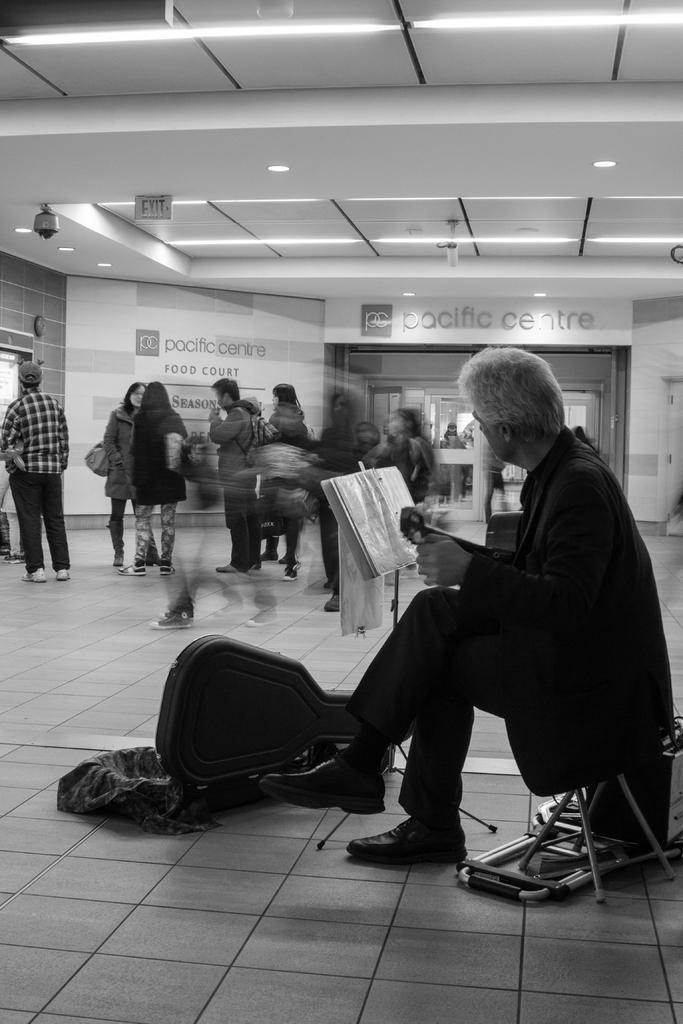How many people are in the image? There is a group of people in the image. What are some of the people in the image doing? Some people are standing, and a man is seated. What object is in front of the seated man? There is a guitar bag in front of the seated man. What can be seen in the background of the image? There are lights visible in the background of the image. How many yaks are present in the image? There are no yaks present in the image. What type of breath can be seen coming from the people in the image? There is no indication of breath in the image, as it is a still photograph. 